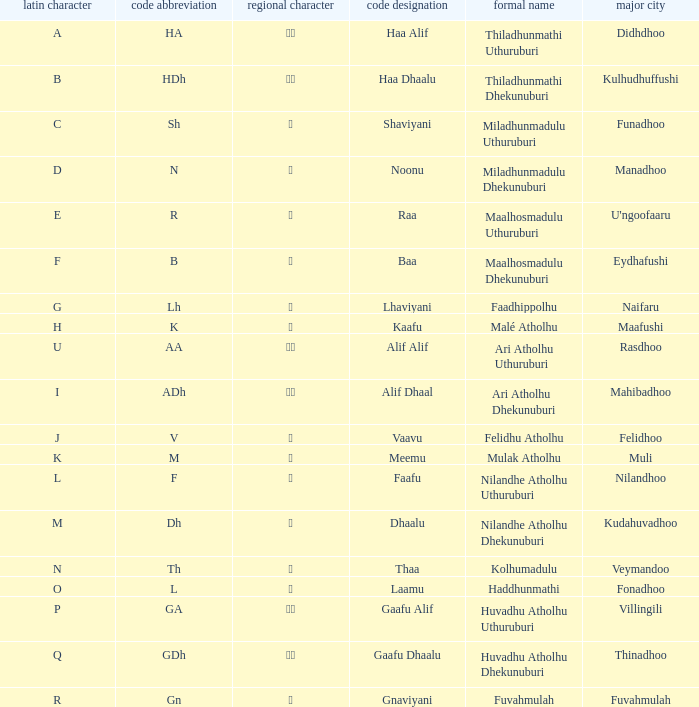The capital of funadhoo has what local letter? ށ. 